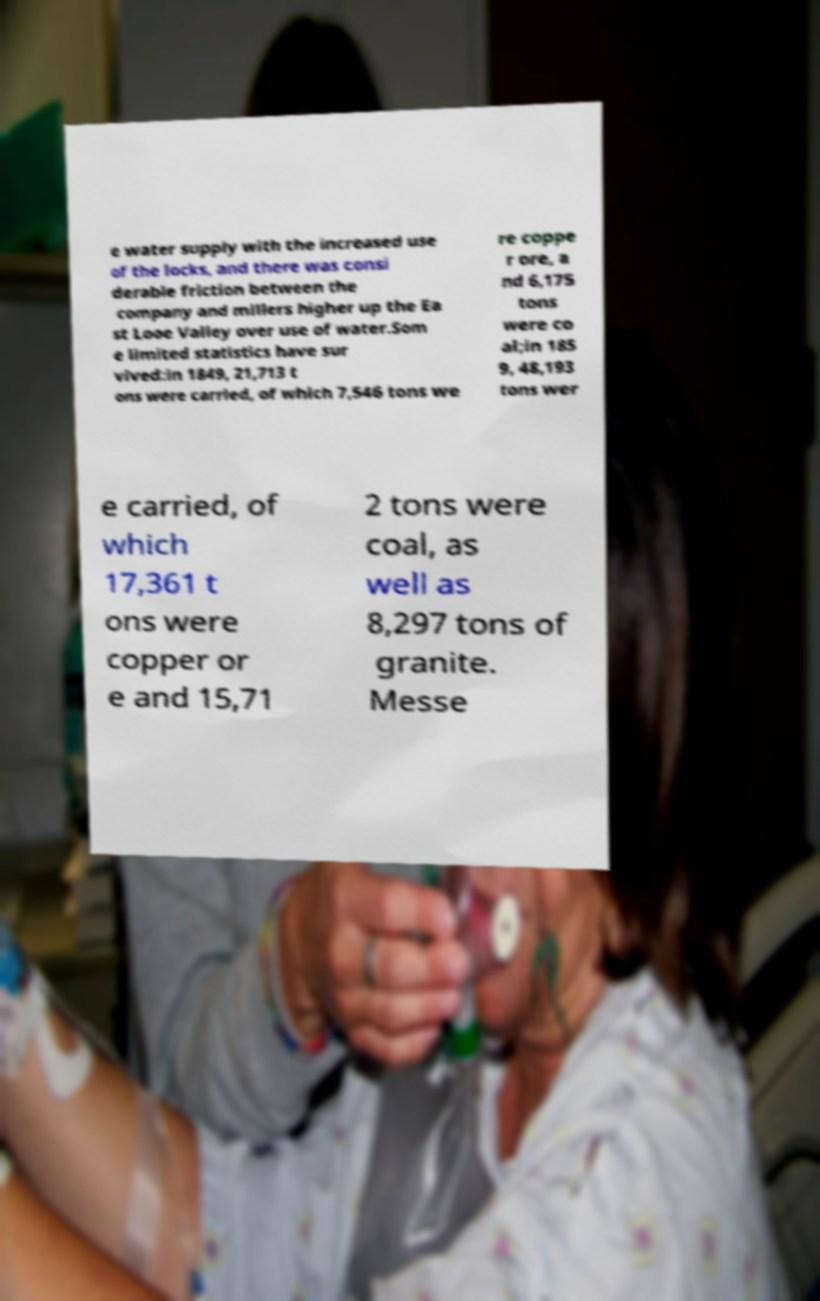Could you extract and type out the text from this image? e water supply with the increased use of the locks, and there was consi derable friction between the company and millers higher up the Ea st Looe Valley over use of water.Som e limited statistics have sur vived:in 1849, 21,713 t ons were carried, of which 7,546 tons we re coppe r ore, a nd 6,175 tons were co al;in 185 9, 48,193 tons wer e carried, of which 17,361 t ons were copper or e and 15,71 2 tons were coal, as well as 8,297 tons of granite. Messe 